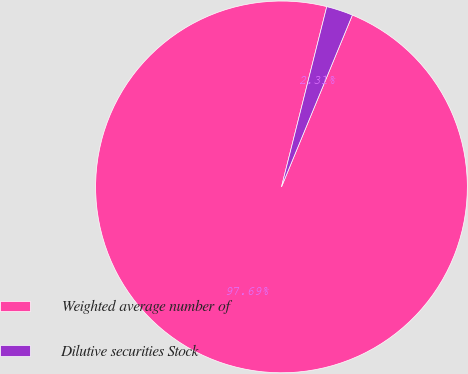Convert chart to OTSL. <chart><loc_0><loc_0><loc_500><loc_500><pie_chart><fcel>Weighted average number of<fcel>Dilutive securities Stock<nl><fcel>97.69%<fcel>2.31%<nl></chart> 